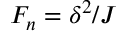Convert formula to latex. <formula><loc_0><loc_0><loc_500><loc_500>F _ { n } = \delta ^ { 2 } / J</formula> 